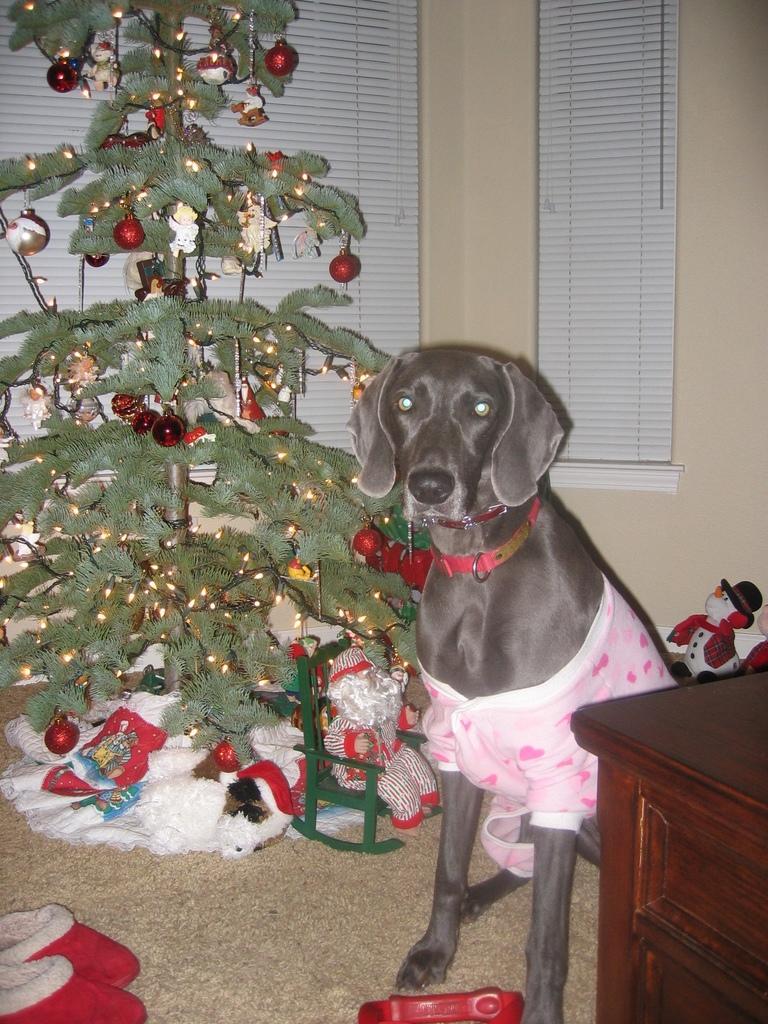Can you describe this image briefly? In this picture there is a dog and a Christmas tree beside him. 